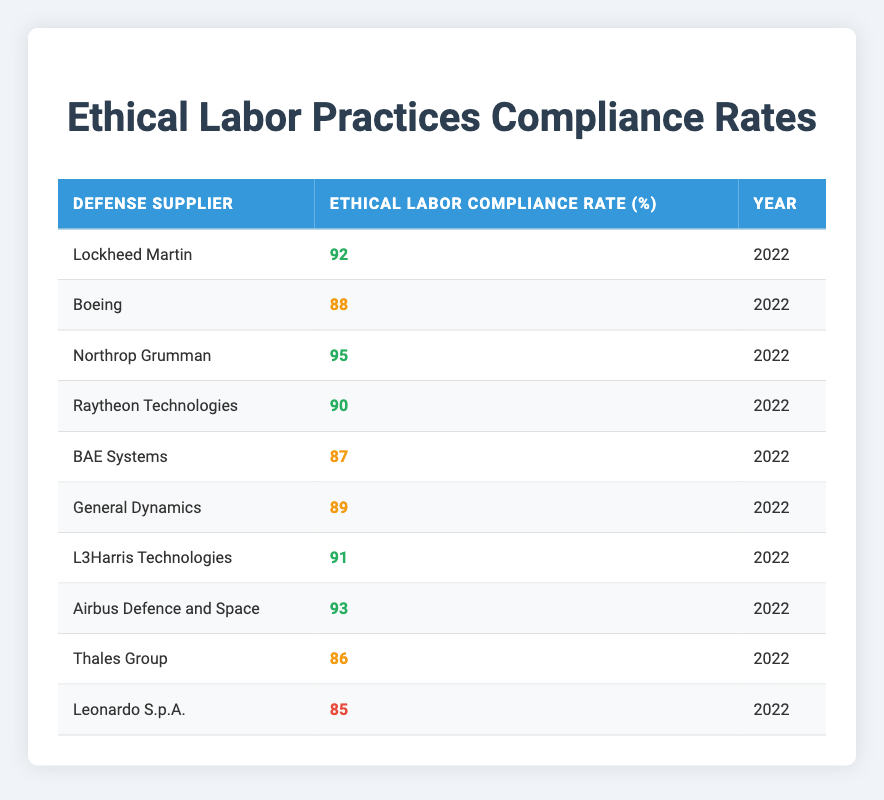What is the compliance rate of Northrop Grumman? The table shows that Northrop Grumman has an Ethical Labor Compliance Rate of 95% in 2022.
Answer: 95 Which defense supplier has the lowest compliance rate? According to the table, Leonardo S.p.A. has the lowest compliance rate of 85% in 2022.
Answer: Leonardo S.p.A What is the average compliance rate among these defense suppliers? To find the average, add together all the compliance rates: 92 + 88 + 95 + 90 + 87 + 89 + 91 + 93 + 86 + 85 = 915. There are 10 suppliers, so the average is 915 / 10 = 91.5.
Answer: 91.5 Is the compliance rate of Raytheon Technologies greater than 89%? The table lists Raytheon Technologies’ compliance rate as 90%, which is indeed greater than 89%.
Answer: Yes How many suppliers have a compliance rate of 90% or higher? From the table, the suppliers with 90% or higher compliance rates are Northrop Grumman, Lockheed Martin, Raytheon Technologies, L3Harris Technologies, Airbus Defence and Space, which makes a total of 5 suppliers.
Answer: 5 What is the difference in compliance rates between the highest and lowest supplier? The highest compliance rate is 95% (Northrop Grumman) and the lowest is 85% (Leonardo S.p.A.). Thus, the difference is 95 - 85 = 10.
Answer: 10 Are there more suppliers with a compliance rate of 85% or above than below 85%? Based on the table, there are 8 suppliers at or above 85% (all except Thales Group and Leonardo S.p.A.), while there are only 2 suppliers below 85%. Therefore, there are more suppliers with a compliance rate of 85% or above.
Answer: Yes What percentage difference is there between the compliance rates of Boeing and L3Harris Technologies? Boeing has a compliance rate of 88% and L3Harris Technologies has a compliance rate of 91%. The percentage difference is calculated as (91 - 88) / 88 * 100 = 3.41%.
Answer: 3.41% 